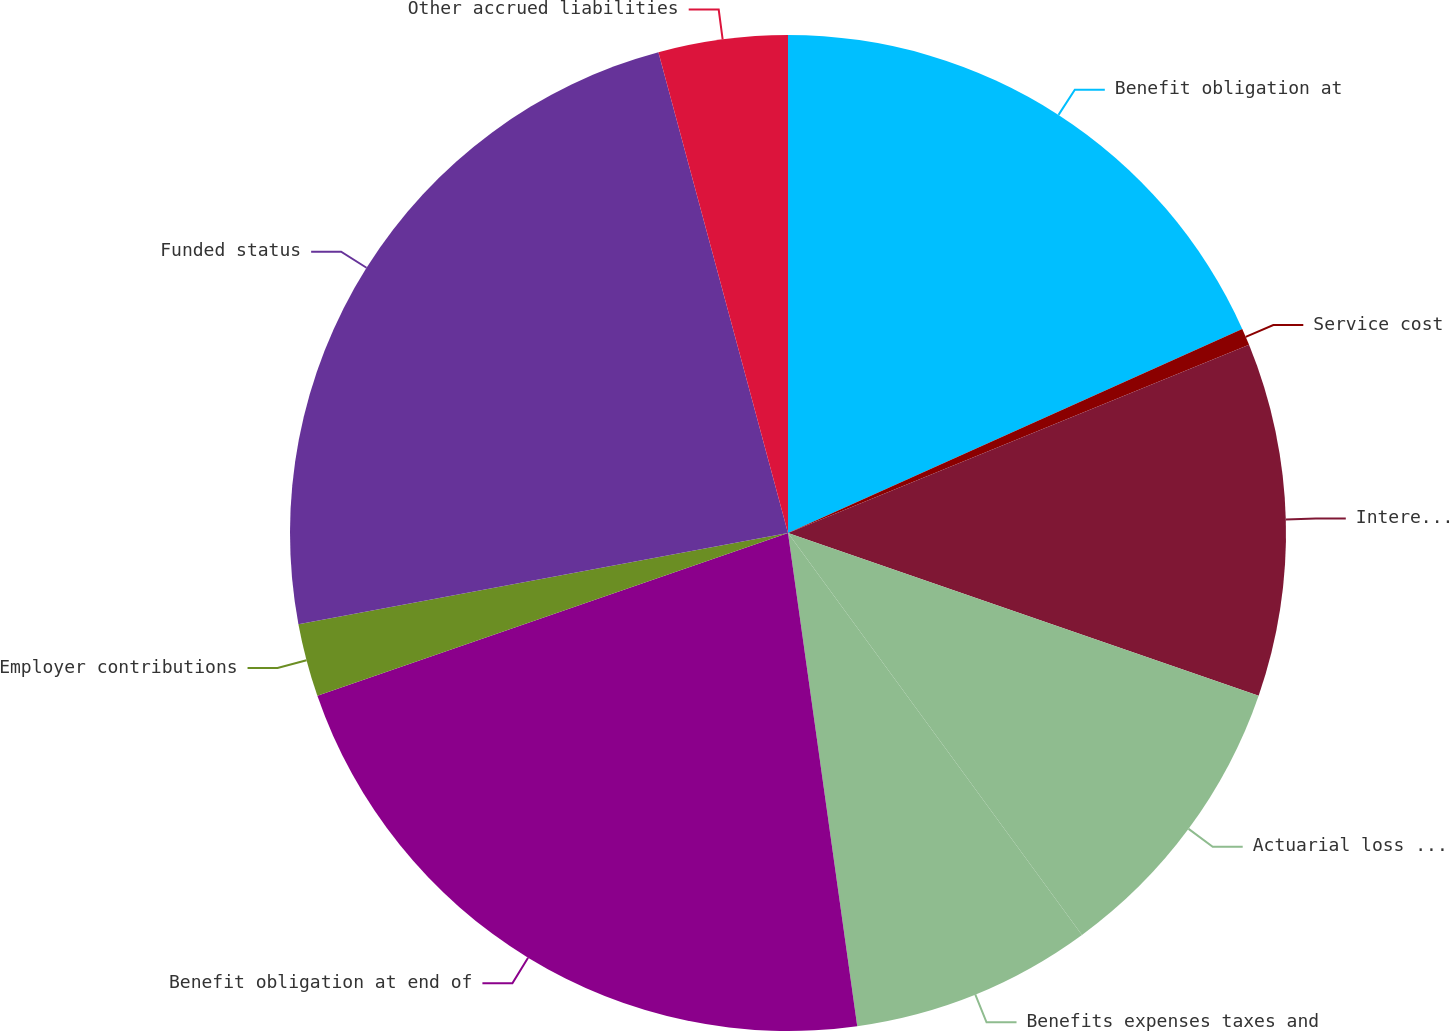Convert chart to OTSL. <chart><loc_0><loc_0><loc_500><loc_500><pie_chart><fcel>Benefit obligation at<fcel>Service cost<fcel>Interest cost<fcel>Actuarial loss (gain)<fcel>Benefits expenses taxes and<fcel>Benefit obligation at end of<fcel>Employer contributions<fcel>Funded status<fcel>Other accrued liabilities<nl><fcel>18.28%<fcel>0.55%<fcel>11.47%<fcel>9.65%<fcel>7.83%<fcel>21.92%<fcel>2.37%<fcel>23.74%<fcel>4.19%<nl></chart> 